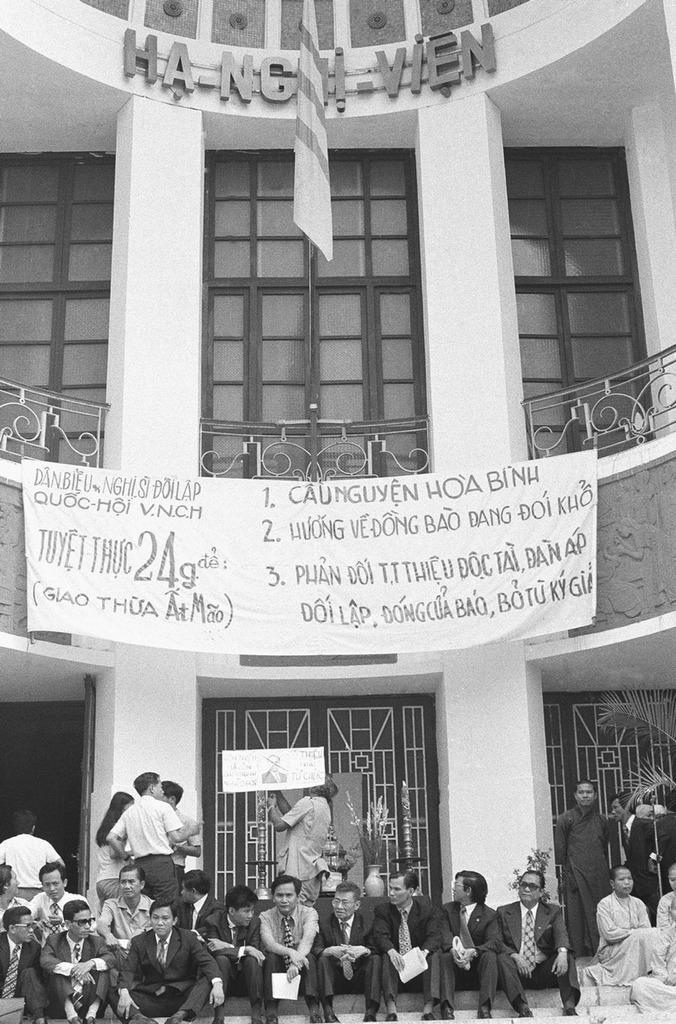In one or two sentences, can you explain what this image depicts? It is a black and white image. In this image we can see the building with the windows. We can also see a banner, board, flag and also a few people standing. We can see a house plant on the right. At the bottom we can see the people sitting on the stairs. 